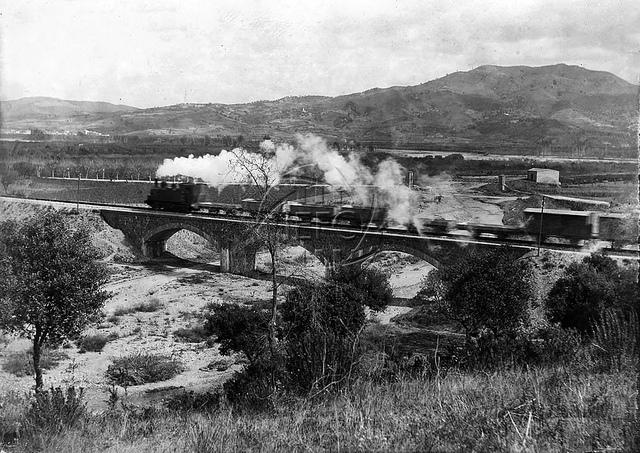What is the train driving over?
Keep it brief. Bridge. Is this a diesel train?
Be succinct. No. Is this picture black and white?
Keep it brief. Yes. 